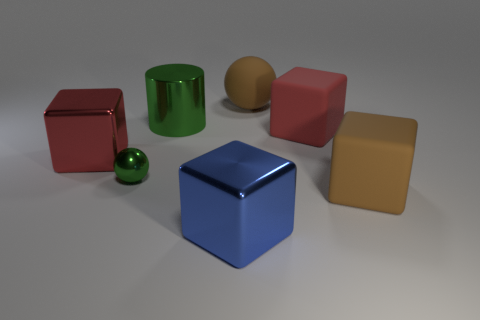What shape is the large red object that is on the left side of the big brown rubber thing that is behind the green object behind the big red matte block?
Provide a short and direct response. Cube. What material is the tiny green ball?
Make the answer very short. Metal. There is a cylinder that is the same material as the tiny green sphere; what is its color?
Make the answer very short. Green. There is a brown thing right of the large red rubber object; are there any large balls that are to the right of it?
Provide a succinct answer. No. How many other things are there of the same shape as the big blue metal object?
Provide a short and direct response. 3. Is the shape of the big brown matte thing behind the green cylinder the same as the green metal object that is on the left side of the large green metallic object?
Provide a short and direct response. Yes. There is a green thing that is in front of the object left of the green sphere; how many blue shiny cubes are in front of it?
Keep it short and to the point. 1. The big cylinder has what color?
Ensure brevity in your answer.  Green. What number of other objects are the same size as the brown matte sphere?
Keep it short and to the point. 5. There is a big blue object that is the same shape as the red rubber thing; what is it made of?
Give a very brief answer. Metal. 